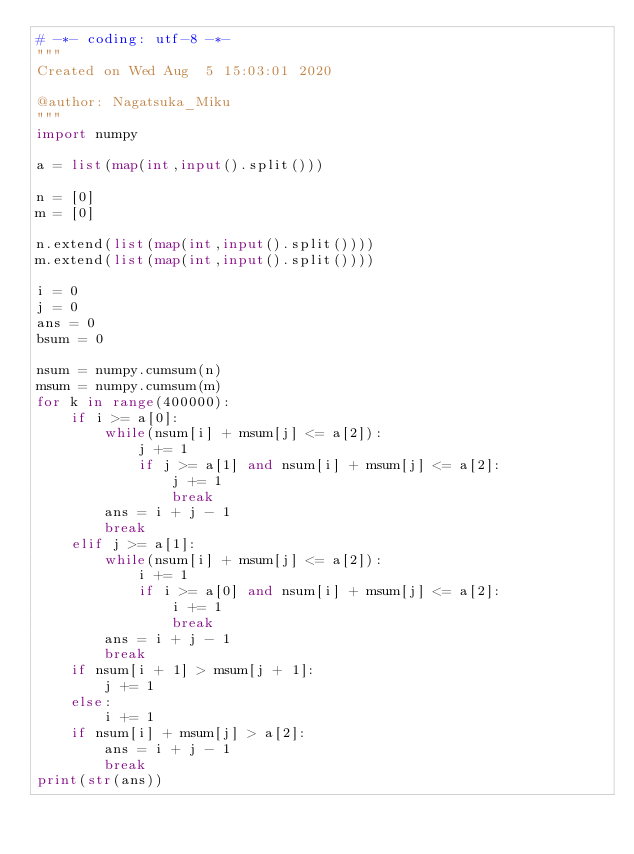Convert code to text. <code><loc_0><loc_0><loc_500><loc_500><_Python_># -*- coding: utf-8 -*-
"""
Created on Wed Aug  5 15:03:01 2020

@author: Nagatsuka_Miku
"""
import numpy

a = list(map(int,input().split()))

n = [0]
m = [0]

n.extend(list(map(int,input().split())))
m.extend(list(map(int,input().split())))

i = 0
j = 0
ans = 0
bsum = 0

nsum = numpy.cumsum(n)
msum = numpy.cumsum(m)
for k in range(400000):
    if i >= a[0]:
        while(nsum[i] + msum[j] <= a[2]):
            j += 1
            if j >= a[1] and nsum[i] + msum[j] <= a[2]:
                j += 1
                break
        ans = i + j - 1
        break
    elif j >= a[1]:
        while(nsum[i] + msum[j] <= a[2]):
            i += 1
            if i >= a[0] and nsum[i] + msum[j] <= a[2]:
                i += 1
                break
        ans = i + j - 1
        break
    if nsum[i + 1] > msum[j + 1]:
        j += 1
    else:
        i += 1
    if nsum[i] + msum[j] > a[2]:
        ans = i + j - 1
        break
print(str(ans))</code> 